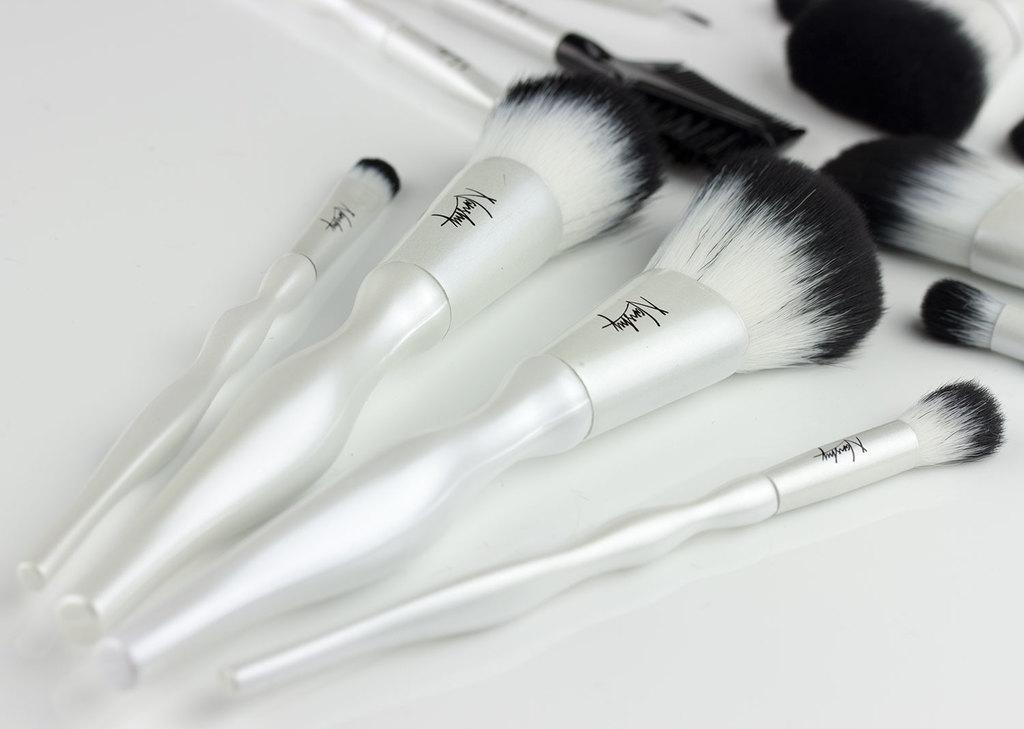What type of objects are present in the image? There are cosmetic brushes in the image. Can you describe the purpose of these objects? Cosmetic brushes are typically used for applying makeup or other cosmetic products. How many cosmetic brushes can be seen in the image? The number of cosmetic brushes in the image is not specified, but there are at least a few visible. What type of bucket is being used to hold the cosmetic brushes in the image? There is no bucket present in the image; the cosmetic brushes are not being held in a bucket. 